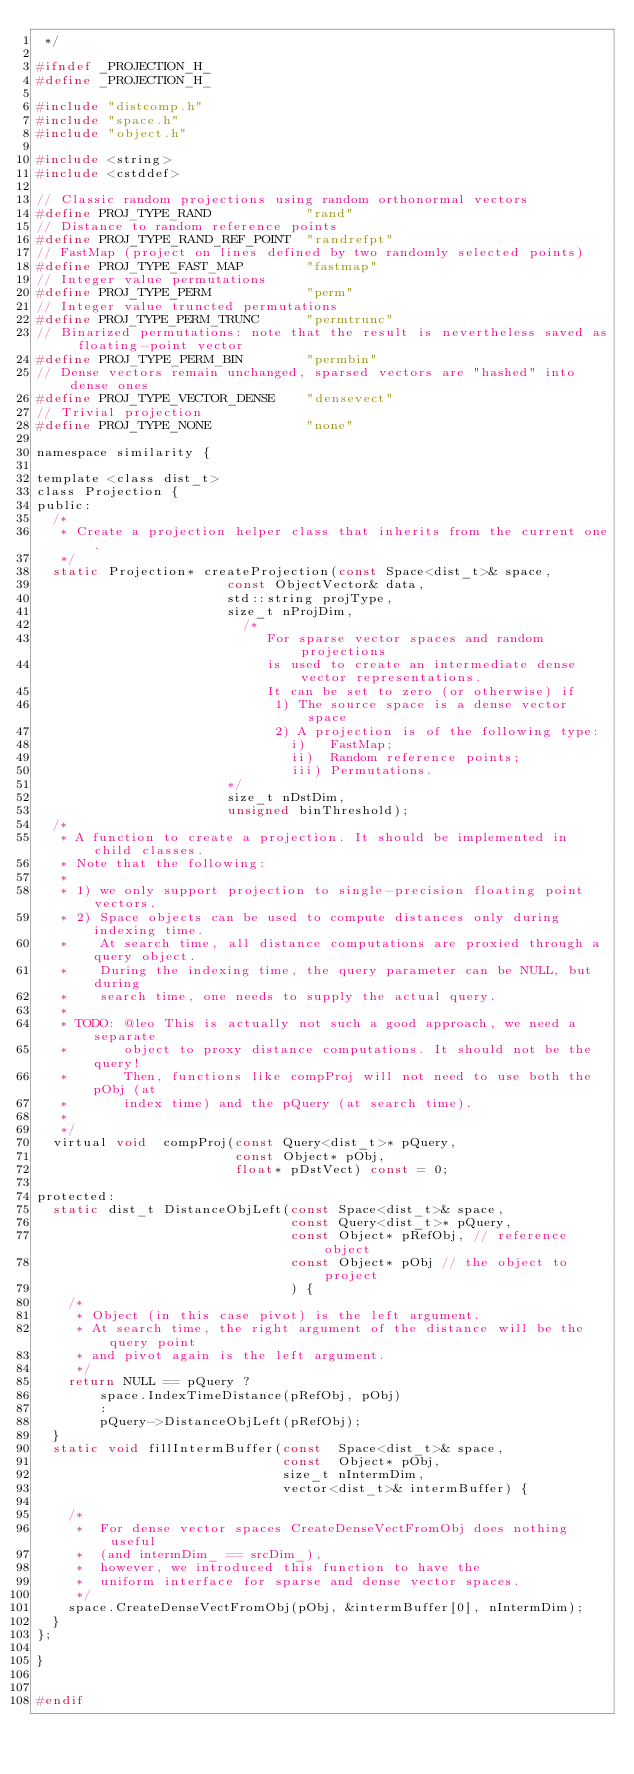<code> <loc_0><loc_0><loc_500><loc_500><_C_> */

#ifndef _PROJECTION_H_
#define _PROJECTION_H_

#include "distcomp.h"
#include "space.h"
#include "object.h"

#include <string>
#include <cstddef>

// Classic random projections using random orthonormal vectors
#define PROJ_TYPE_RAND            "rand"          
// Distance to random reference points
#define PROJ_TYPE_RAND_REF_POINT  "randrefpt"     
// FastMap (project on lines defined by two randomly selected points)
#define PROJ_TYPE_FAST_MAP        "fastmap"       
// Integer value permutations
#define PROJ_TYPE_PERM            "perm"
// Integer value truncted permutations
#define PROJ_TYPE_PERM_TRUNC      "permtrunc"
// Binarized permutations: note that the result is nevertheless saved as floating-point vector
#define PROJ_TYPE_PERM_BIN        "permbin"
// Dense vectors remain unchanged, sparsed vectors are "hashed" into dense ones
#define PROJ_TYPE_VECTOR_DENSE    "densevect"
// Trivial projection
#define PROJ_TYPE_NONE            "none"

namespace similarity {

template <class dist_t>
class Projection {
public:
  /*
   * Create a projection helper class that inherits from the current one.
   */
  static Projection* createProjection(const Space<dist_t>& space,
                        const ObjectVector& data,
                        std::string projType,
                        size_t nProjDim,
                          /*
                             For sparse vector spaces and random projections
                             is used to create an intermediate dense vector representations.
                             It can be set to zero (or otherwise) if
                              1) The source space is a dense vector space
                              2) A projection is of the following type:
                                i)   FastMap;
                                ii)  Random reference points;
                                iii) Permutations.
                        */
                        size_t nDstDim,
                        unsigned binThreshold);
  /*
   * A function to create a projection. It should be implemented in child classes.
   * Note that the following:
   *
   * 1) we only support projection to single-precision floating point vectors.
   * 2) Space objects can be used to compute distances only during indexing time.
   *    At search time, all distance computations are proxied through a query object.
   *    During the indexing time, the query parameter can be NULL, but during
   *    search time, one needs to supply the actual query.
   *
   * TODO: @leo This is actually not such a good approach, we need a separate
   *       object to proxy distance computations. It should not be the query!
   *       Then, functions like compProj will not need to use both the pObj (at
   *       index time) and the pQuery (at search time).
   *
   */
  virtual void  compProj(const Query<dist_t>* pQuery,
                         const Object* pObj,
                         float* pDstVect) const = 0;

protected:
  static dist_t DistanceObjLeft(const Space<dist_t>& space,
                                const Query<dist_t>* pQuery,
                                const Object* pRefObj, // reference object
                                const Object* pObj // the object to project
                                ) {
    /*
     * Object (in this case pivot) is the left argument.
     * At search time, the right argument of the distance will be the query point
     * and pivot again is the left argument.
     */
    return NULL == pQuery ?
        space.IndexTimeDistance(pRefObj, pObj)
        :
        pQuery->DistanceObjLeft(pRefObj);
  }
  static void fillIntermBuffer(const  Space<dist_t>& space,
                               const  Object* pObj,
                               size_t nIntermDim,
                               vector<dist_t>& intermBuffer) {

    /*
     *  For dense vector spaces CreateDenseVectFromObj does nothing useful
     *  (and intermDim_ == srcDim_),
     *  however, we introduced this function to have the
     *  uniform interface for sparse and dense vector spaces.
     */
    space.CreateDenseVectFromObj(pObj, &intermBuffer[0], nIntermDim);
  }
};

}


#endif
</code> 